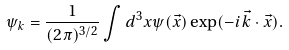Convert formula to latex. <formula><loc_0><loc_0><loc_500><loc_500>\psi _ { k } = \frac { 1 } { ( 2 \pi ) ^ { 3 / 2 } } \int d ^ { 3 } x \psi ( { \vec { x } } ) \exp ( - i { \vec { k } } \cdot { \vec { x } } ) .</formula> 